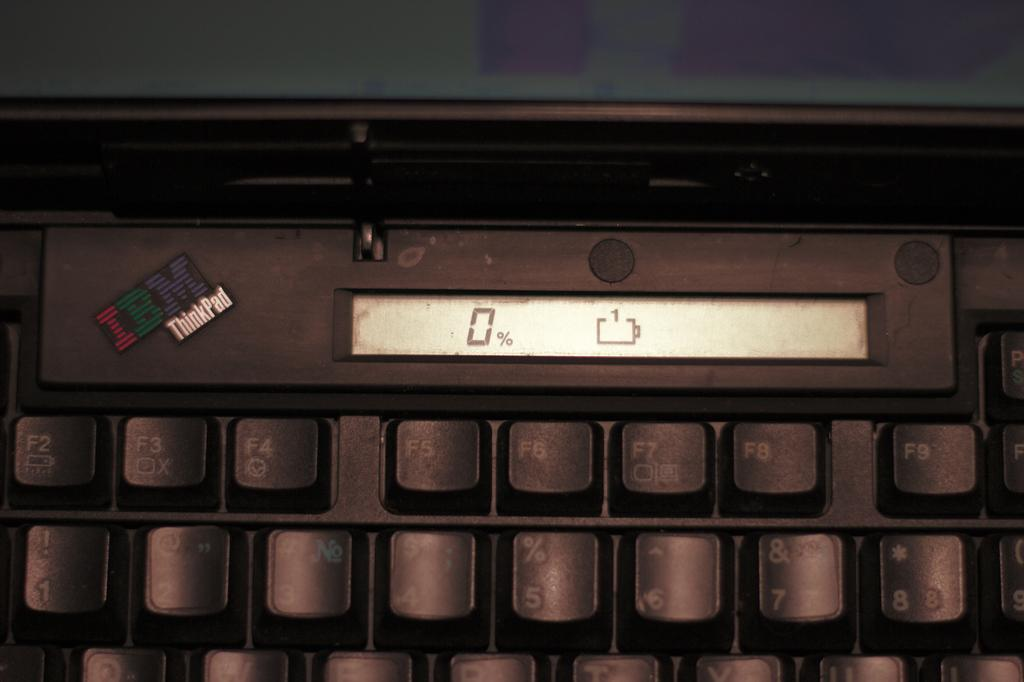What is the main object visible in the image? There is a keyboard in the image. What type of yoke is connected to the keyboard in the image? There is no yoke connected to the keyboard in the image. Is the keyboard being used for flight control in the image? The image does not show any flight control or any context that would suggest the keyboard is being used for that purpose. 